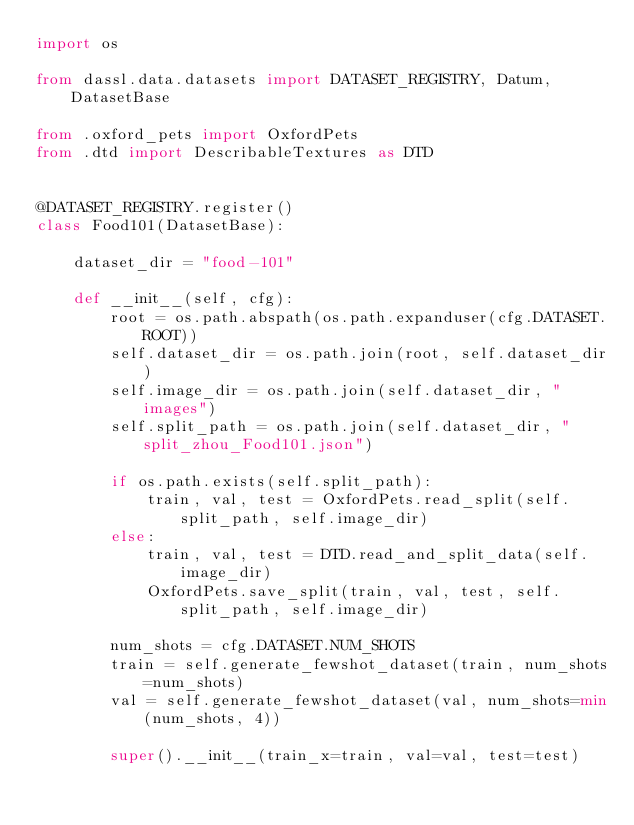<code> <loc_0><loc_0><loc_500><loc_500><_Python_>import os

from dassl.data.datasets import DATASET_REGISTRY, Datum, DatasetBase

from .oxford_pets import OxfordPets
from .dtd import DescribableTextures as DTD


@DATASET_REGISTRY.register()
class Food101(DatasetBase):

    dataset_dir = "food-101"

    def __init__(self, cfg):
        root = os.path.abspath(os.path.expanduser(cfg.DATASET.ROOT))
        self.dataset_dir = os.path.join(root, self.dataset_dir)
        self.image_dir = os.path.join(self.dataset_dir, "images")
        self.split_path = os.path.join(self.dataset_dir, "split_zhou_Food101.json")

        if os.path.exists(self.split_path):
            train, val, test = OxfordPets.read_split(self.split_path, self.image_dir)
        else:
            train, val, test = DTD.read_and_split_data(self.image_dir)
            OxfordPets.save_split(train, val, test, self.split_path, self.image_dir)

        num_shots = cfg.DATASET.NUM_SHOTS
        train = self.generate_fewshot_dataset(train, num_shots=num_shots)
        val = self.generate_fewshot_dataset(val, num_shots=min(num_shots, 4))

        super().__init__(train_x=train, val=val, test=test)
</code> 